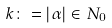<formula> <loc_0><loc_0><loc_500><loc_500>k \colon = | \alpha | \in N _ { 0 }</formula> 